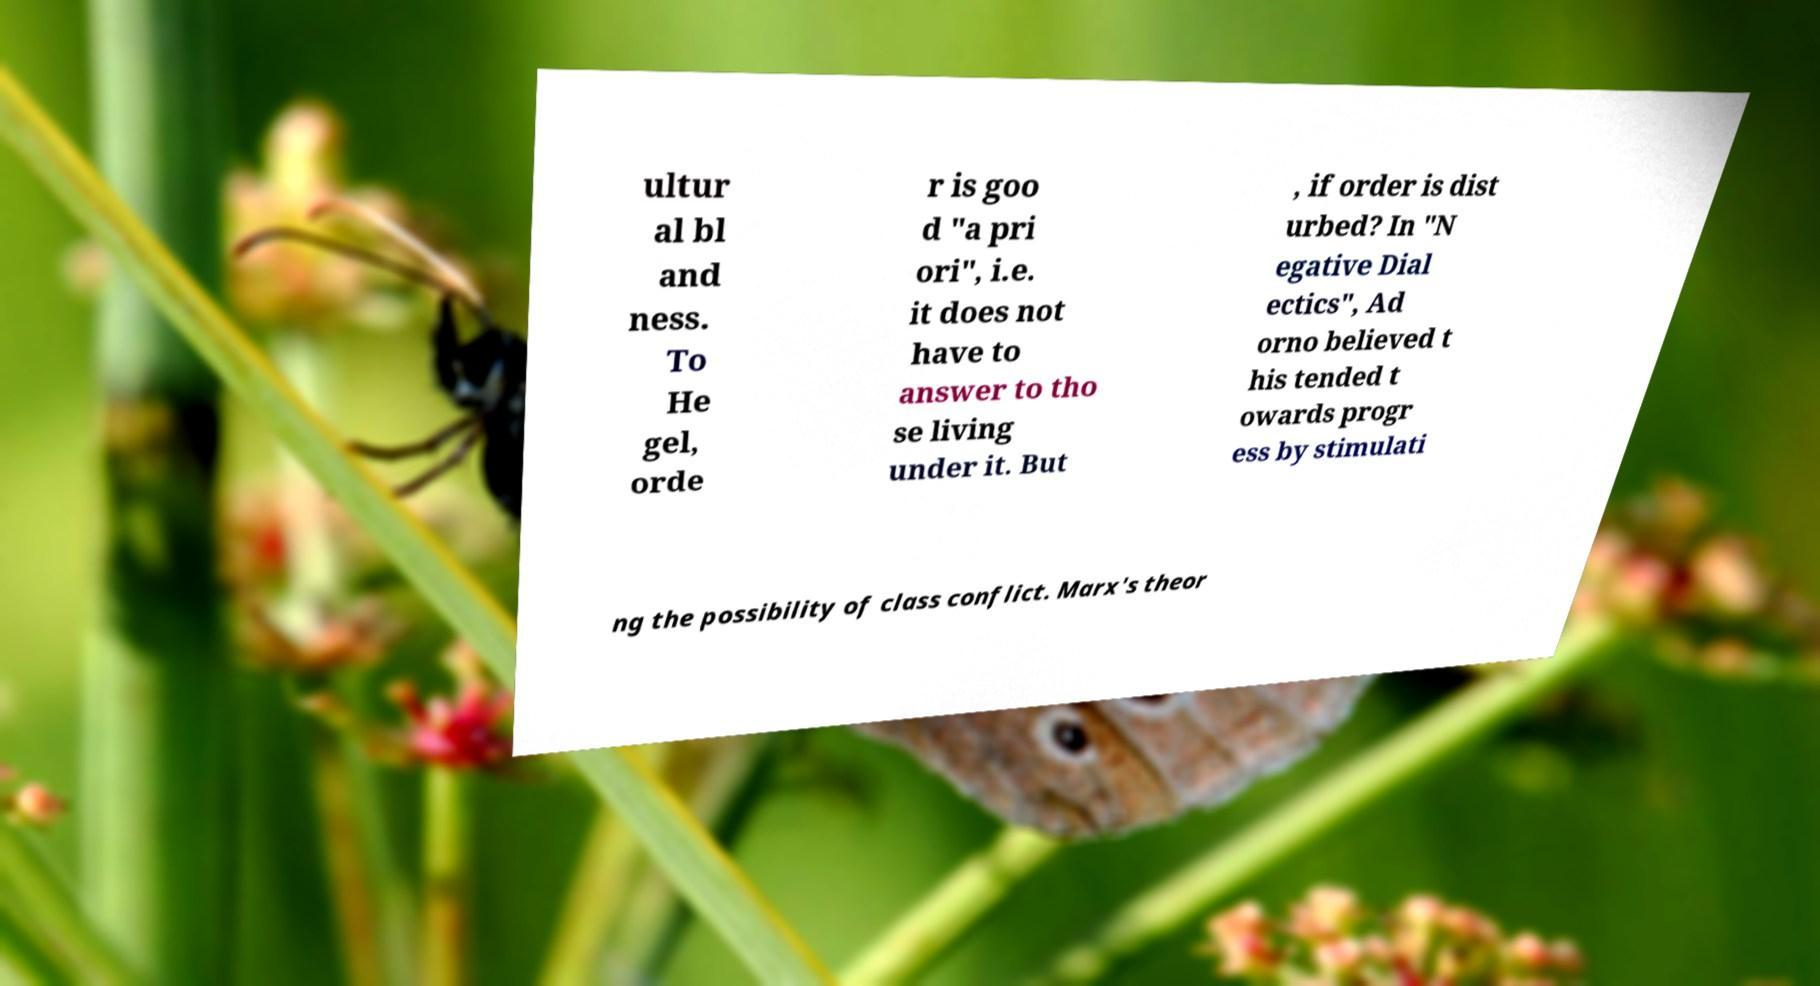Can you read and provide the text displayed in the image?This photo seems to have some interesting text. Can you extract and type it out for me? ultur al bl and ness. To He gel, orde r is goo d "a pri ori", i.e. it does not have to answer to tho se living under it. But , if order is dist urbed? In "N egative Dial ectics", Ad orno believed t his tended t owards progr ess by stimulati ng the possibility of class conflict. Marx's theor 